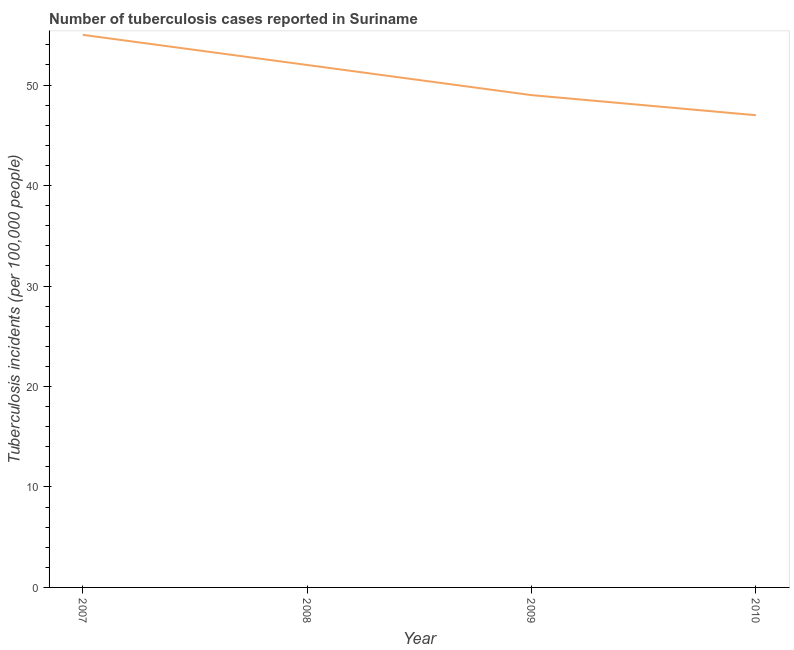What is the number of tuberculosis incidents in 2009?
Your answer should be very brief. 49. Across all years, what is the maximum number of tuberculosis incidents?
Keep it short and to the point. 55. Across all years, what is the minimum number of tuberculosis incidents?
Provide a succinct answer. 47. In which year was the number of tuberculosis incidents maximum?
Provide a short and direct response. 2007. In which year was the number of tuberculosis incidents minimum?
Keep it short and to the point. 2010. What is the sum of the number of tuberculosis incidents?
Make the answer very short. 203. What is the difference between the number of tuberculosis incidents in 2008 and 2009?
Provide a succinct answer. 3. What is the average number of tuberculosis incidents per year?
Provide a succinct answer. 50.75. What is the median number of tuberculosis incidents?
Make the answer very short. 50.5. Do a majority of the years between 2009 and 2008 (inclusive) have number of tuberculosis incidents greater than 12 ?
Provide a succinct answer. No. What is the ratio of the number of tuberculosis incidents in 2008 to that in 2009?
Make the answer very short. 1.06. Is the difference between the number of tuberculosis incidents in 2007 and 2010 greater than the difference between any two years?
Keep it short and to the point. Yes. What is the difference between the highest and the second highest number of tuberculosis incidents?
Your answer should be compact. 3. What is the difference between the highest and the lowest number of tuberculosis incidents?
Your answer should be compact. 8. How many lines are there?
Your answer should be very brief. 1. How many years are there in the graph?
Your response must be concise. 4. What is the difference between two consecutive major ticks on the Y-axis?
Provide a short and direct response. 10. Does the graph contain grids?
Make the answer very short. No. What is the title of the graph?
Your answer should be very brief. Number of tuberculosis cases reported in Suriname. What is the label or title of the X-axis?
Ensure brevity in your answer.  Year. What is the label or title of the Y-axis?
Provide a succinct answer. Tuberculosis incidents (per 100,0 people). What is the Tuberculosis incidents (per 100,000 people) in 2008?
Your response must be concise. 52. What is the difference between the Tuberculosis incidents (per 100,000 people) in 2007 and 2008?
Your answer should be very brief. 3. What is the difference between the Tuberculosis incidents (per 100,000 people) in 2007 and 2009?
Provide a succinct answer. 6. What is the difference between the Tuberculosis incidents (per 100,000 people) in 2008 and 2009?
Provide a succinct answer. 3. What is the difference between the Tuberculosis incidents (per 100,000 people) in 2008 and 2010?
Your answer should be compact. 5. What is the difference between the Tuberculosis incidents (per 100,000 people) in 2009 and 2010?
Your answer should be compact. 2. What is the ratio of the Tuberculosis incidents (per 100,000 people) in 2007 to that in 2008?
Provide a short and direct response. 1.06. What is the ratio of the Tuberculosis incidents (per 100,000 people) in 2007 to that in 2009?
Offer a very short reply. 1.12. What is the ratio of the Tuberculosis incidents (per 100,000 people) in 2007 to that in 2010?
Provide a succinct answer. 1.17. What is the ratio of the Tuberculosis incidents (per 100,000 people) in 2008 to that in 2009?
Your answer should be very brief. 1.06. What is the ratio of the Tuberculosis incidents (per 100,000 people) in 2008 to that in 2010?
Provide a succinct answer. 1.11. What is the ratio of the Tuberculosis incidents (per 100,000 people) in 2009 to that in 2010?
Make the answer very short. 1.04. 